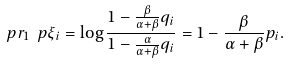Convert formula to latex. <formula><loc_0><loc_0><loc_500><loc_500>\ p r _ { 1 } \ p { \xi _ { i } = \log \frac { 1 - \frac { \beta } { \alpha + \beta } q _ { i } } { 1 - \frac { \alpha } { \alpha + \beta } q _ { i } } } = 1 - \frac { \beta } { \alpha + \beta } p _ { i } .</formula> 